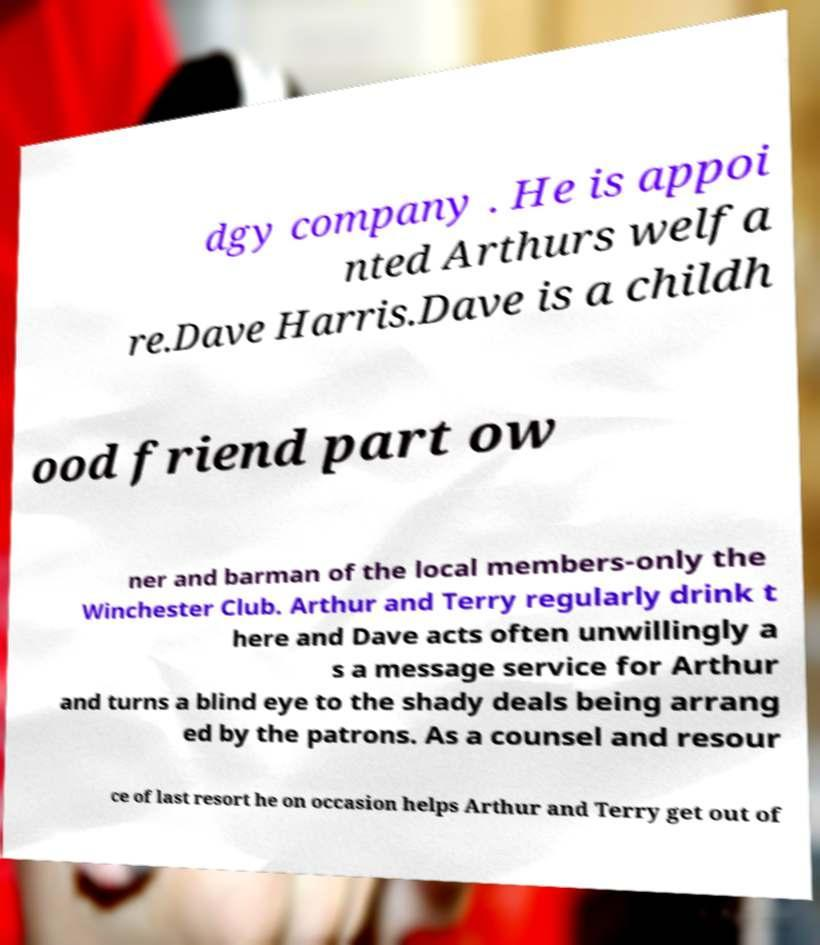Please read and relay the text visible in this image. What does it say? dgy company . He is appoi nted Arthurs welfa re.Dave Harris.Dave is a childh ood friend part ow ner and barman of the local members-only the Winchester Club. Arthur and Terry regularly drink t here and Dave acts often unwillingly a s a message service for Arthur and turns a blind eye to the shady deals being arrang ed by the patrons. As a counsel and resour ce of last resort he on occasion helps Arthur and Terry get out of 